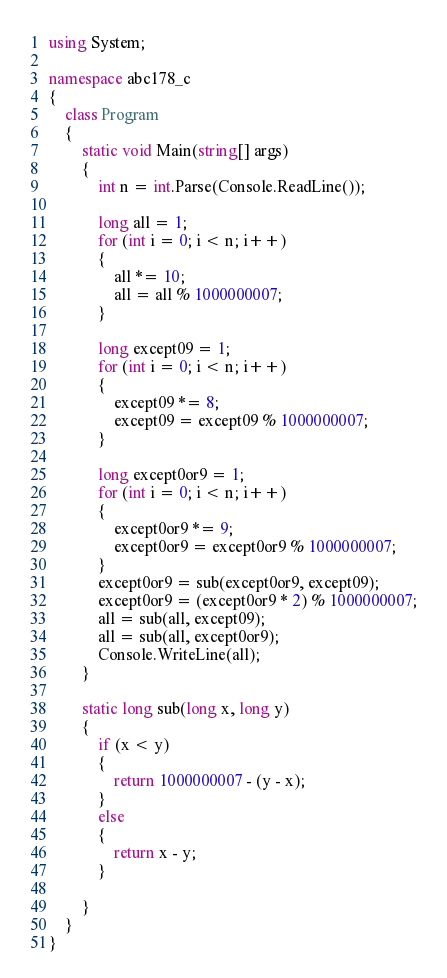Convert code to text. <code><loc_0><loc_0><loc_500><loc_500><_C#_>using System;

namespace abc178_c
{
    class Program
    {
        static void Main(string[] args)
        {
            int n = int.Parse(Console.ReadLine());

            long all = 1;
            for (int i = 0; i < n; i++)
            {
                all *= 10;
                all = all % 1000000007;
            }

            long except09 = 1;
            for (int i = 0; i < n; i++)
            {
                except09 *= 8;
                except09 = except09 % 1000000007;
            }

            long except0or9 = 1;
            for (int i = 0; i < n; i++)
            {
                except0or9 *= 9;
                except0or9 = except0or9 % 1000000007;
            }
            except0or9 = sub(except0or9, except09);
            except0or9 = (except0or9 * 2) % 1000000007;
            all = sub(all, except09);
            all = sub(all, except0or9);
            Console.WriteLine(all);
        }

        static long sub(long x, long y)
        {
            if (x < y)
            {
                return 1000000007 - (y - x);
            }
            else
            {
                return x - y;
            }

        }
    }
}
</code> 